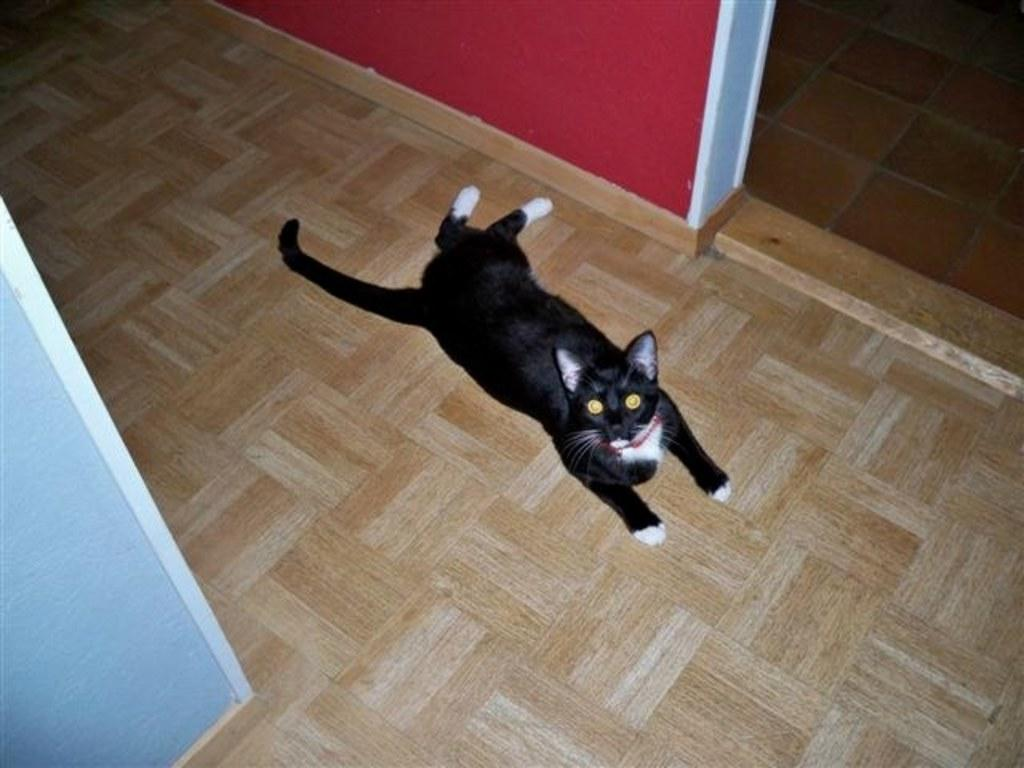What type of animal is in the image? There is a cat in the image. Can you describe the color pattern of the cat? The cat is white and black in color. What is the cat lying on in the image? The cat is lying on a brown surface. What can be seen in the background of the image? There is a wall in the image. What colors are present on the wall? The wall has red, blue, and white colors. What type of beef is the cat eating in the image? There is no beef present in the image; the cat is lying on a brown surface and not eating anything. 